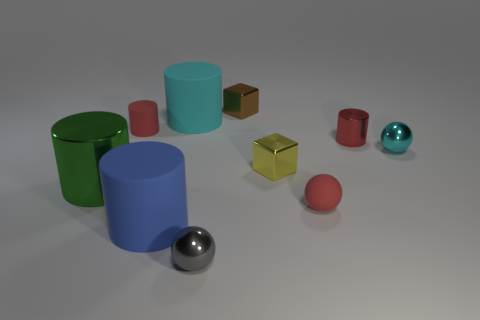Subtract all small shiny balls. How many balls are left? 1 Subtract all yellow cubes. How many cubes are left? 1 Subtract all blocks. How many objects are left? 8 Subtract 1 spheres. How many spheres are left? 2 Subtract all brown cubes. Subtract all gray cylinders. How many cubes are left? 1 Subtract all red cubes. How many red cylinders are left? 2 Subtract all small gray shiny objects. Subtract all yellow metallic spheres. How many objects are left? 9 Add 1 large cylinders. How many large cylinders are left? 4 Add 3 large yellow objects. How many large yellow objects exist? 3 Subtract 0 purple cylinders. How many objects are left? 10 